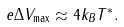<formula> <loc_0><loc_0><loc_500><loc_500>e \Delta V _ { \max } \approx 4 k _ { B } T ^ { \ast } .</formula> 